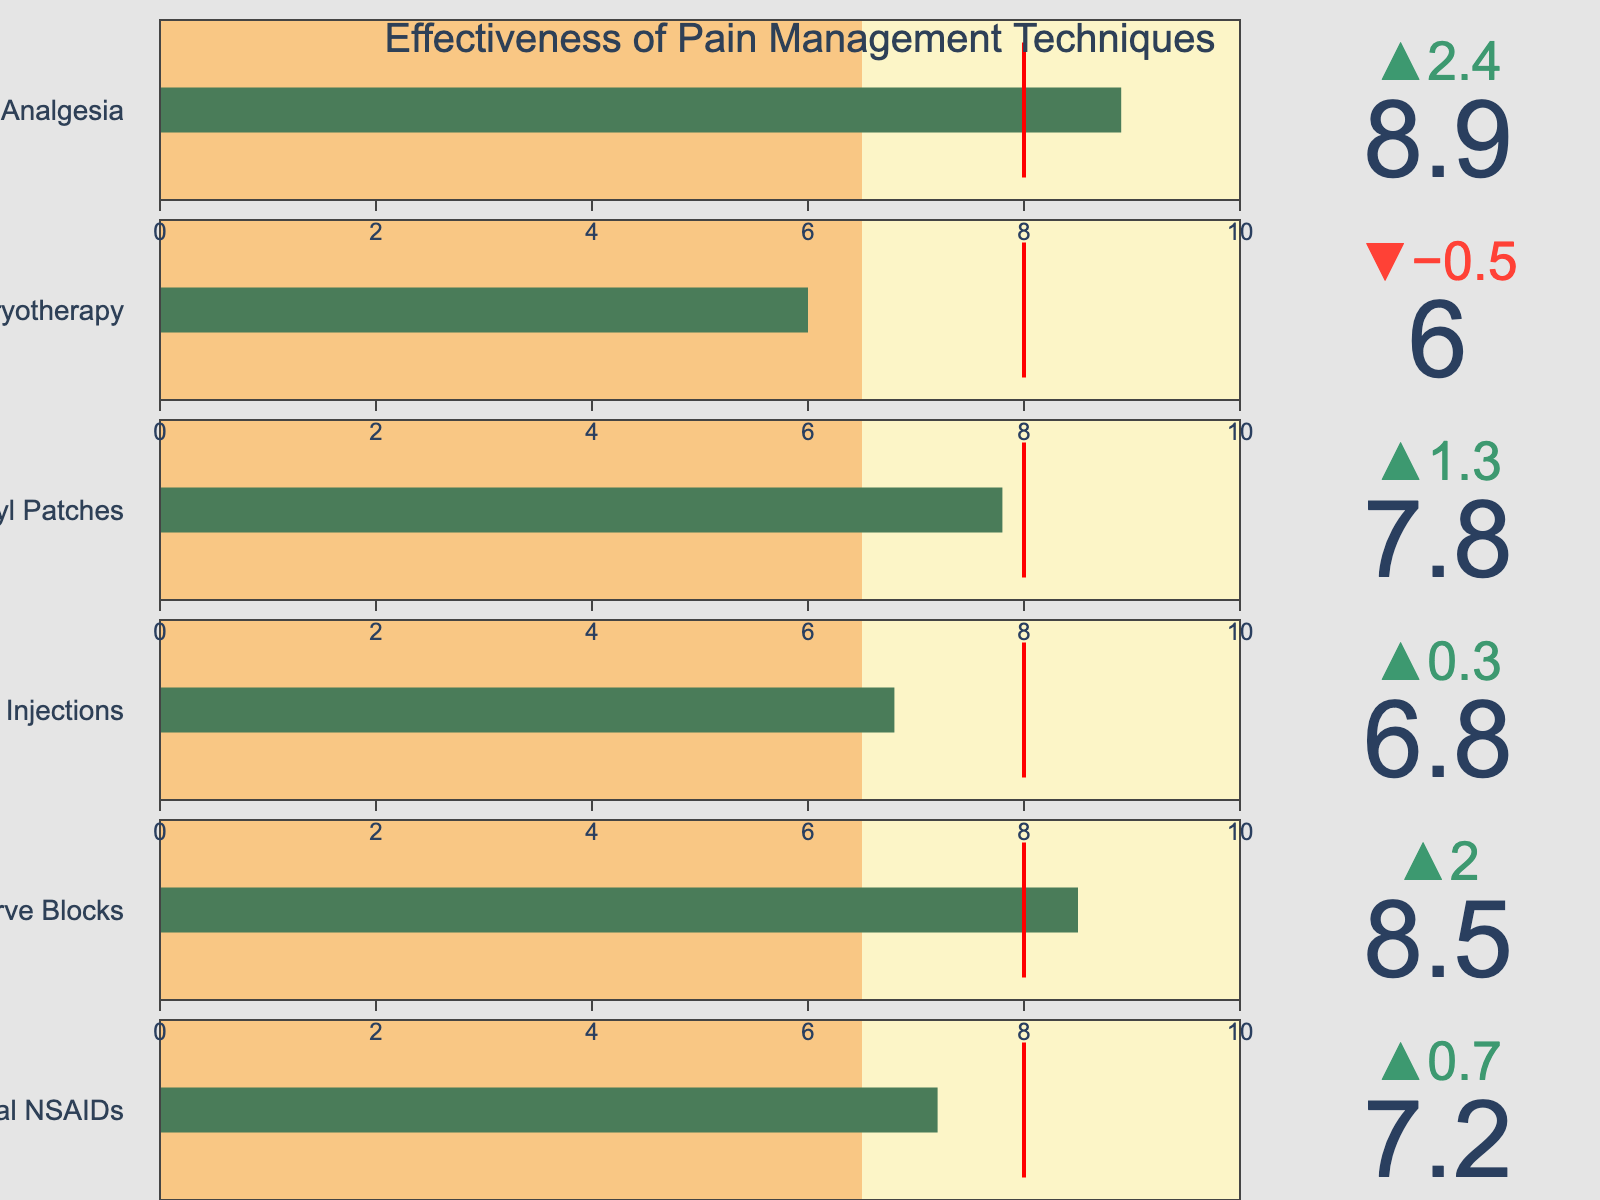What is the title of the figure? The title is usually prominently displayed at the top of the figure. It helps in understanding the context of the chart. In this case, the title is "Effectiveness of Pain Management Techniques."
Answer: Effectiveness of Pain Management Techniques Which pain management technique has the highest effectiveness score? Look at the bullet chart; for each technique, the effectiveness score will be presented as the main value. The technique with the highest score is "Multimodal Analgesia" with a score of 8.9.
Answer: Multimodal Analgesia How does the effectiveness score of "Cryotherapy" compare to the average score? To answer this, locate the score for Cryotherapy and compare it to its average score. Cryotherapy has an effectiveness score of 6.0, while the average score is 6.5. It is below the average score.
Answer: Below the average What is the difference between the target score and the effectiveness score for "Opioid Injections"? Find the target score (8.0) and effectiveness score (6.8) for Opioid Injections and subtract the effectiveness score from the target score to get the difference: 8.0 - 6.8.
Answer: 1.2 Which technique is closest to meeting the target score of 8.0? Compare the effectiveness scores to the target of 8.0 and find the one closest to 8.0. "Transdermal Fentanyl Patches" has an effectiveness score of 7.8, which is closest to 8.0.
Answer: Transdermal Fentanyl Patches How many techniques exceed the average score of 6.5? Count the number of techniques where the effectiveness score is greater than 6.5. "Oral NSAIDs," "Local Nerve Blocks," "Transdermal Fentanyl Patches," and "Multimodal Analgesia" exceed the average.
Answer: 4 Which technique shows the largest delta difference from the average score? The delta difference is shown at the top of each bullet chart. The largest delta difference is seen for Multimodal Analgesia, which has the highest score above the average score.
Answer: Multimodal Analgesia What color indicates the effectiveness bar in the bullet chart? The bar representing the effectiveness score in the bullet chart is colored to help distinguish it. In this case, the bar is colored green.
Answer: Green 